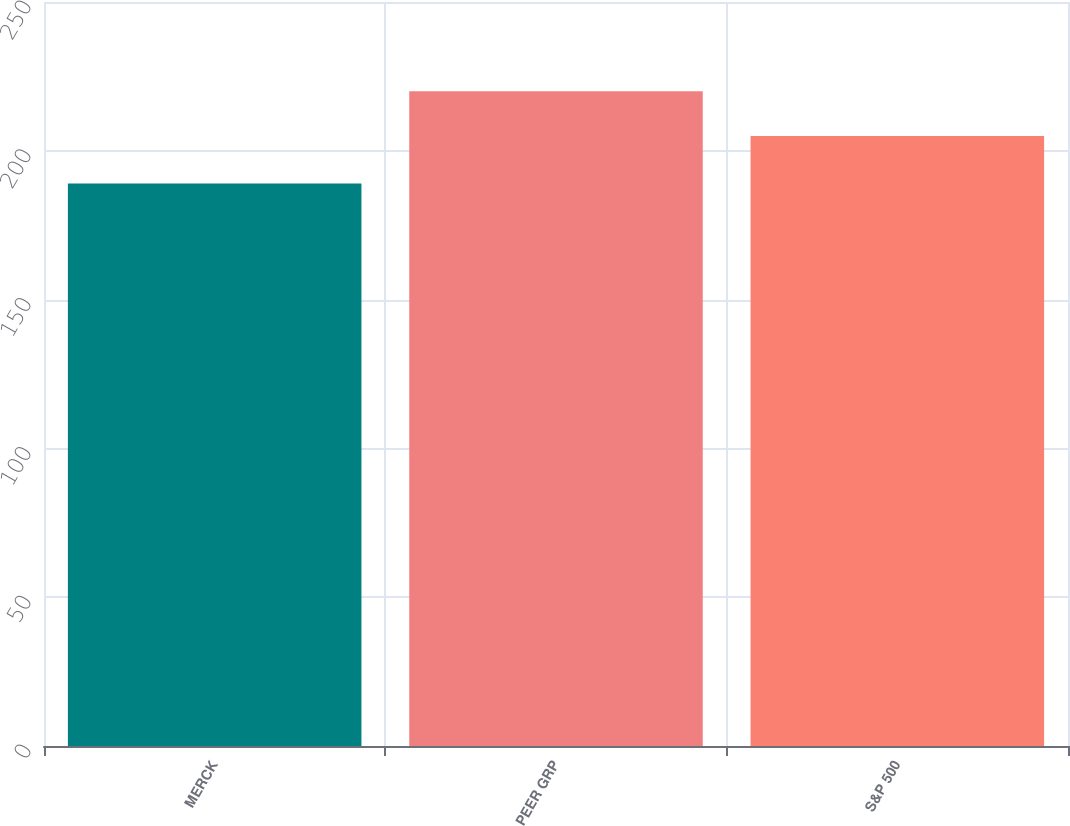<chart> <loc_0><loc_0><loc_500><loc_500><bar_chart><fcel>MERCK<fcel>PEER GRP<fcel>S&P 500<nl><fcel>189<fcel>220<fcel>205<nl></chart> 